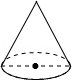Convey your observations regarding the picture. The image depicts a cone-shaped mold with a circular base. This geometric diagram shows distinct demarcations around the base, possibly indicating measurement units or sections for reference. The apex and the base are connected by a generatrix line, suggesting the slant height of the cone. This type of illustration could be used for educational purposes, explaining concepts of geometry, specifically the elements of a cone. 